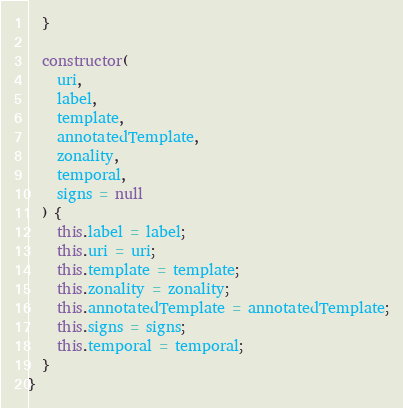Convert code to text. <code><loc_0><loc_0><loc_500><loc_500><_JavaScript_>  }

  constructor(
    uri,
    label,
    template,
    annotatedTemplate,
    zonality,
    temporal,
    signs = null
  ) {
    this.label = label;
    this.uri = uri;
    this.template = template;
    this.zonality = zonality;
    this.annotatedTemplate = annotatedTemplate;
    this.signs = signs;
    this.temporal = temporal;
  }
}
</code> 